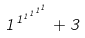Convert formula to latex. <formula><loc_0><loc_0><loc_500><loc_500>1 ^ { 1 ^ { 1 ^ { 1 ^ { 1 ^ { 1 } } } } } + 3</formula> 